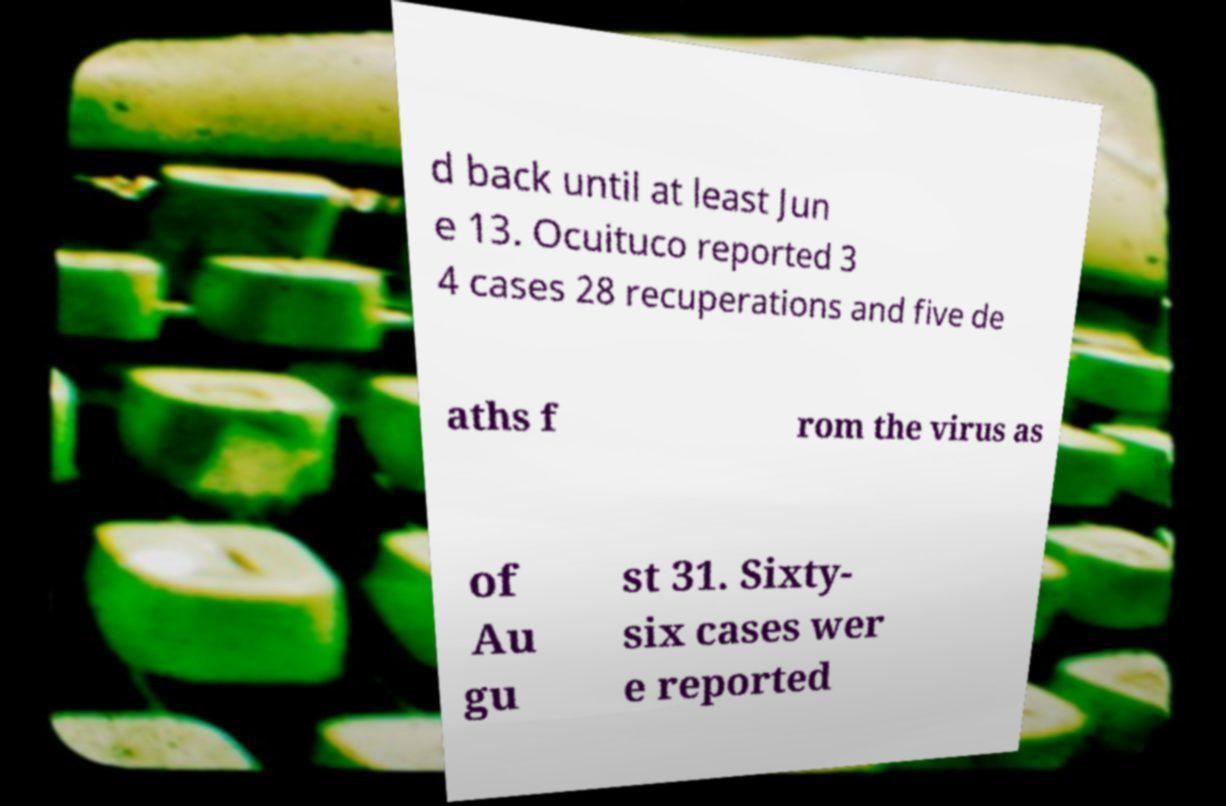Please identify and transcribe the text found in this image. d back until at least Jun e 13. Ocuituco reported 3 4 cases 28 recuperations and five de aths f rom the virus as of Au gu st 31. Sixty- six cases wer e reported 